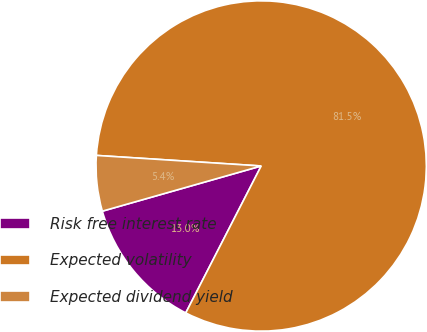<chart> <loc_0><loc_0><loc_500><loc_500><pie_chart><fcel>Risk free interest rate<fcel>Expected volatility<fcel>Expected dividend yield<nl><fcel>13.04%<fcel>81.52%<fcel>5.43%<nl></chart> 